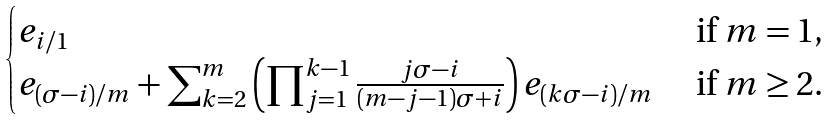<formula> <loc_0><loc_0><loc_500><loc_500>\begin{cases} e _ { i / 1 } & \text { if } m = 1 , \\ e _ { ( \sigma - i ) / m } + \sum _ { k = 2 } ^ { m } \left ( \prod _ { j = 1 } ^ { k - 1 } \frac { j \sigma - i } { ( m - j - 1 ) \sigma + i } \right ) e _ { ( k \sigma - i ) / m } & \text { if } m \geq 2 . \end{cases}</formula> 